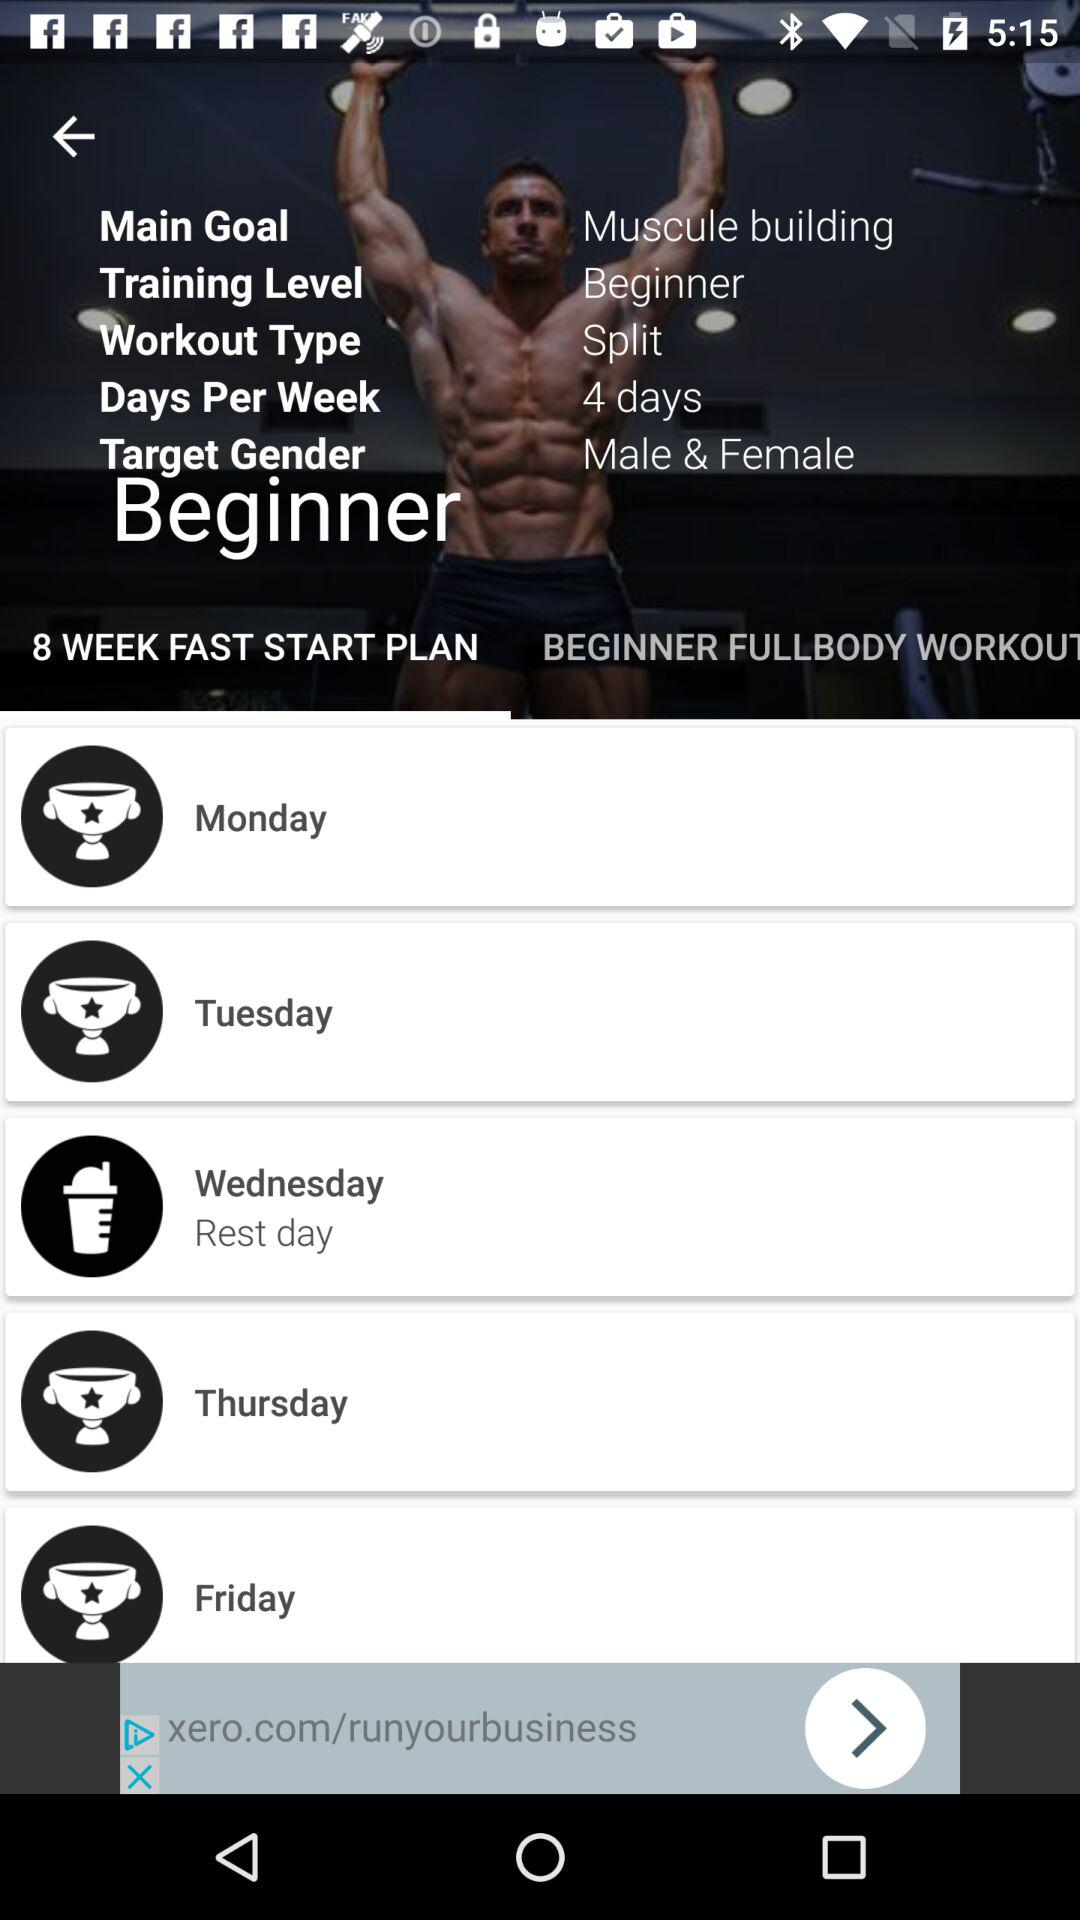How many days per week are there? There are 4 days per week. 